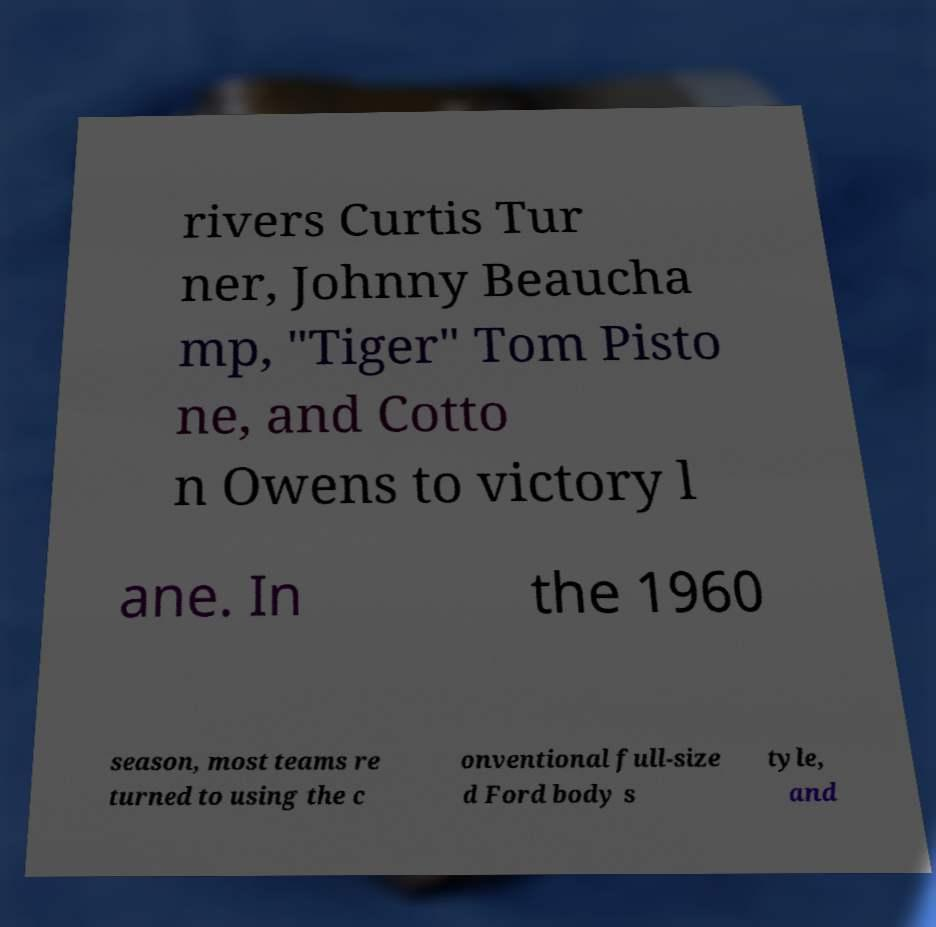Could you assist in decoding the text presented in this image and type it out clearly? rivers Curtis Tur ner, Johnny Beaucha mp, "Tiger" Tom Pisto ne, and Cotto n Owens to victory l ane. In the 1960 season, most teams re turned to using the c onventional full-size d Ford body s tyle, and 